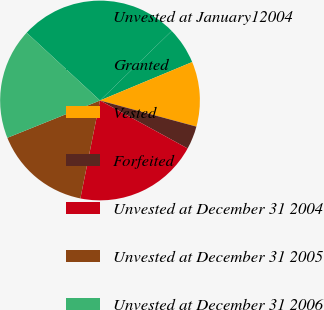Convert chart. <chart><loc_0><loc_0><loc_500><loc_500><pie_chart><fcel>Unvested at January12004<fcel>Granted<fcel>Vested<fcel>Forfeited<fcel>Unvested at December 31 2004<fcel>Unvested at December 31 2005<fcel>Unvested at December 31 2006<nl><fcel>25.87%<fcel>5.97%<fcel>10.5%<fcel>3.76%<fcel>20.18%<fcel>15.76%<fcel>17.97%<nl></chart> 